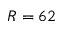Convert formula to latex. <formula><loc_0><loc_0><loc_500><loc_500>R = 6 2</formula> 